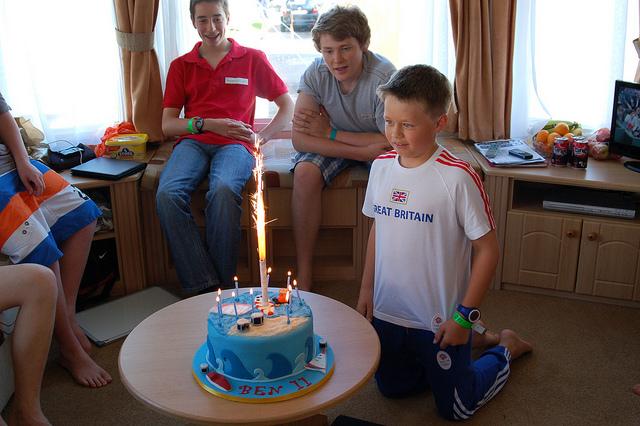How old is the boy who is kneeling?
Short answer required. 11. Is this a birthday party for Grandpa?
Answer briefly. No. How many stripes on the birthday boys clothes?
Write a very short answer. 3. 